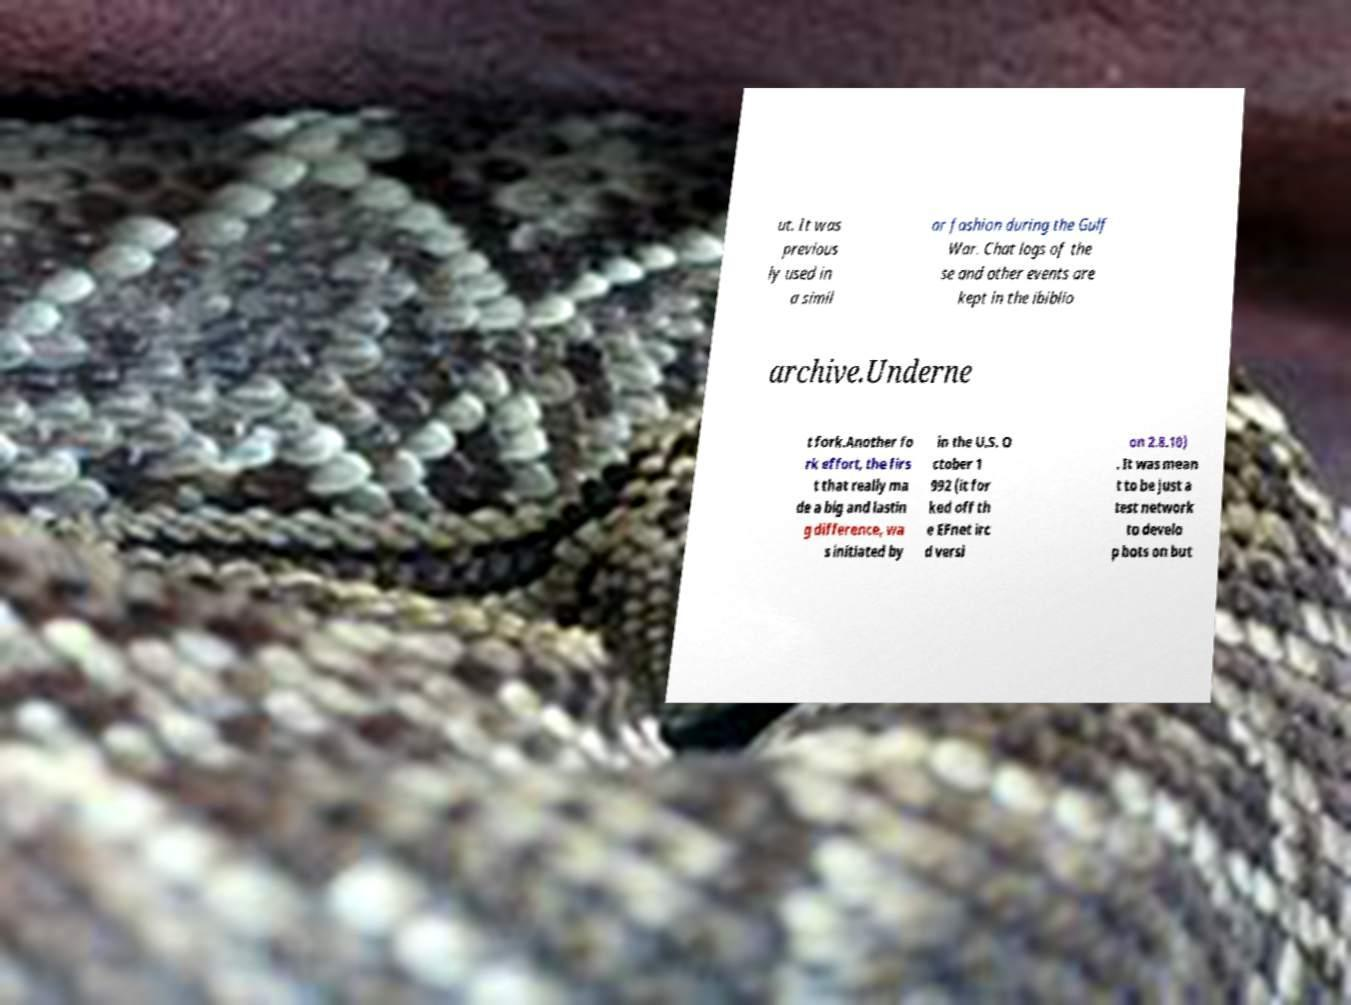Can you accurately transcribe the text from the provided image for me? ut. It was previous ly used in a simil ar fashion during the Gulf War. Chat logs of the se and other events are kept in the ibiblio archive.Underne t fork.Another fo rk effort, the firs t that really ma de a big and lastin g difference, wa s initiated by in the U.S. O ctober 1 992 (it for ked off th e EFnet irc d versi on 2.8.10) . It was mean t to be just a test network to develo p bots on but 